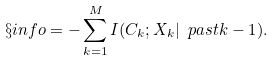<formula> <loc_0><loc_0><loc_500><loc_500>\S i n f o = - \sum _ { k = 1 } ^ { M } I ( C _ { k } ; X _ { k } | \ p a s t { k - 1 } ) .</formula> 